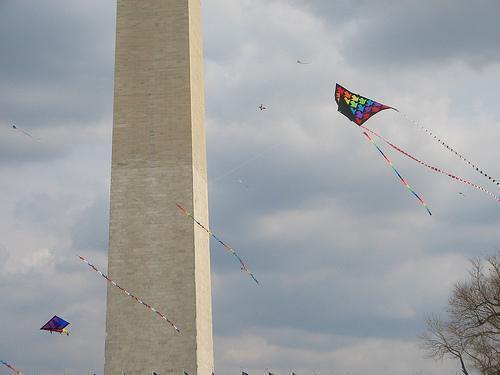How many kites are there?
Give a very brief answer. 5. How many trees are there?
Give a very brief answer. 1. 